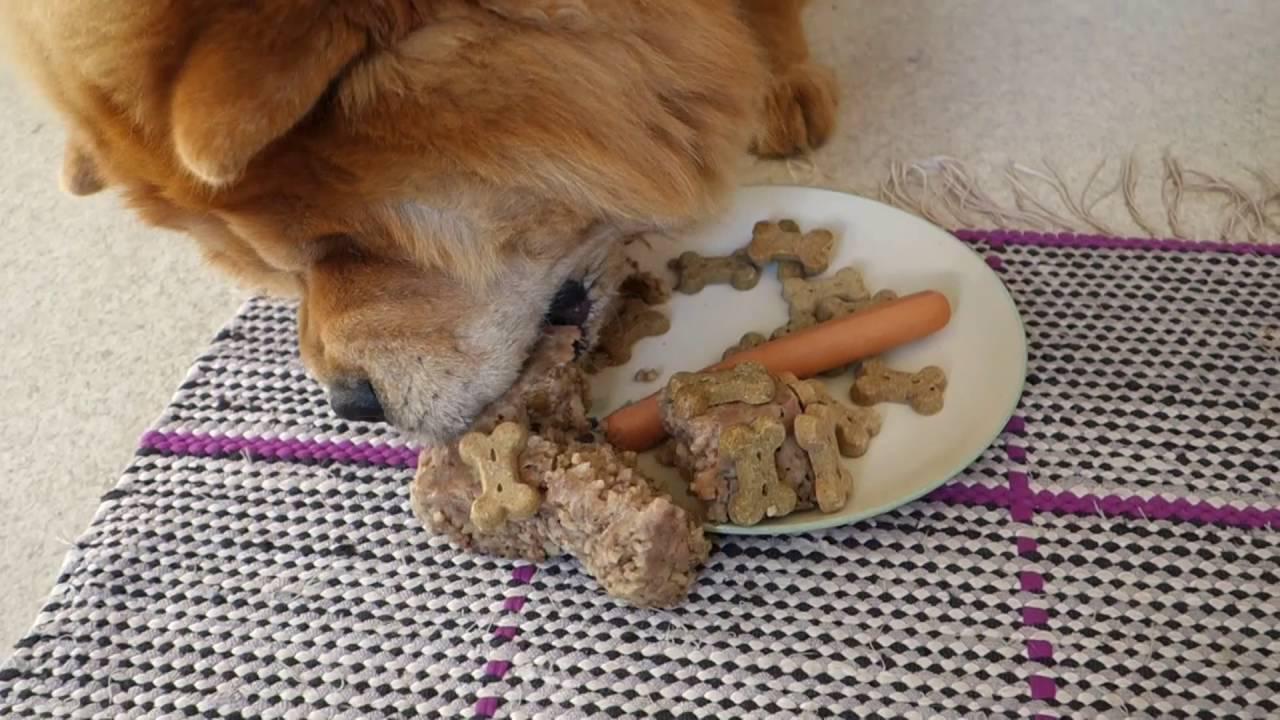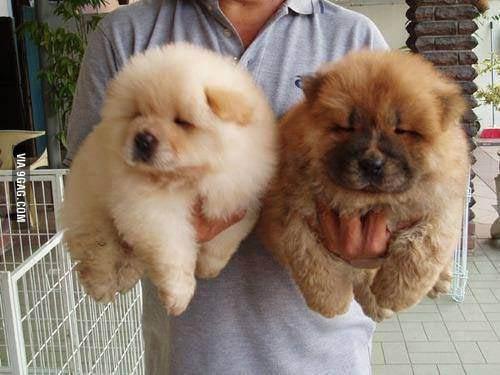The first image is the image on the left, the second image is the image on the right. Assess this claim about the two images: "A dog is eating food.". Correct or not? Answer yes or no. Yes. The first image is the image on the left, the second image is the image on the right. For the images shown, is this caption "there are 3 dogs in the image pair" true? Answer yes or no. Yes. 